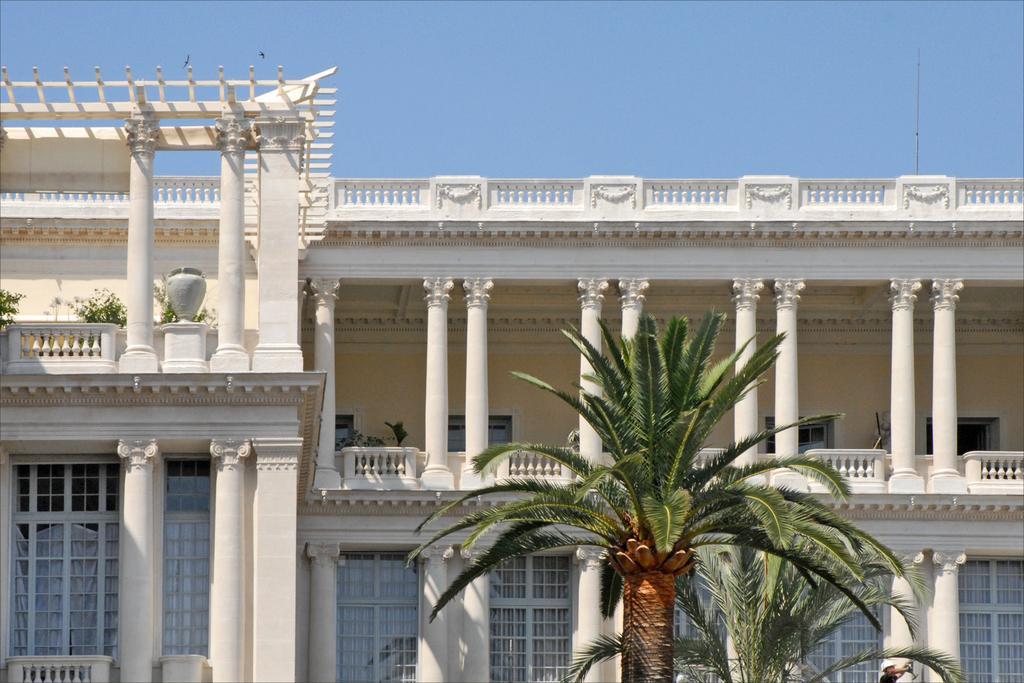Please provide a concise description of this image. In this picture I can see trees, a building, plants, a person, and in the background there is sky. 